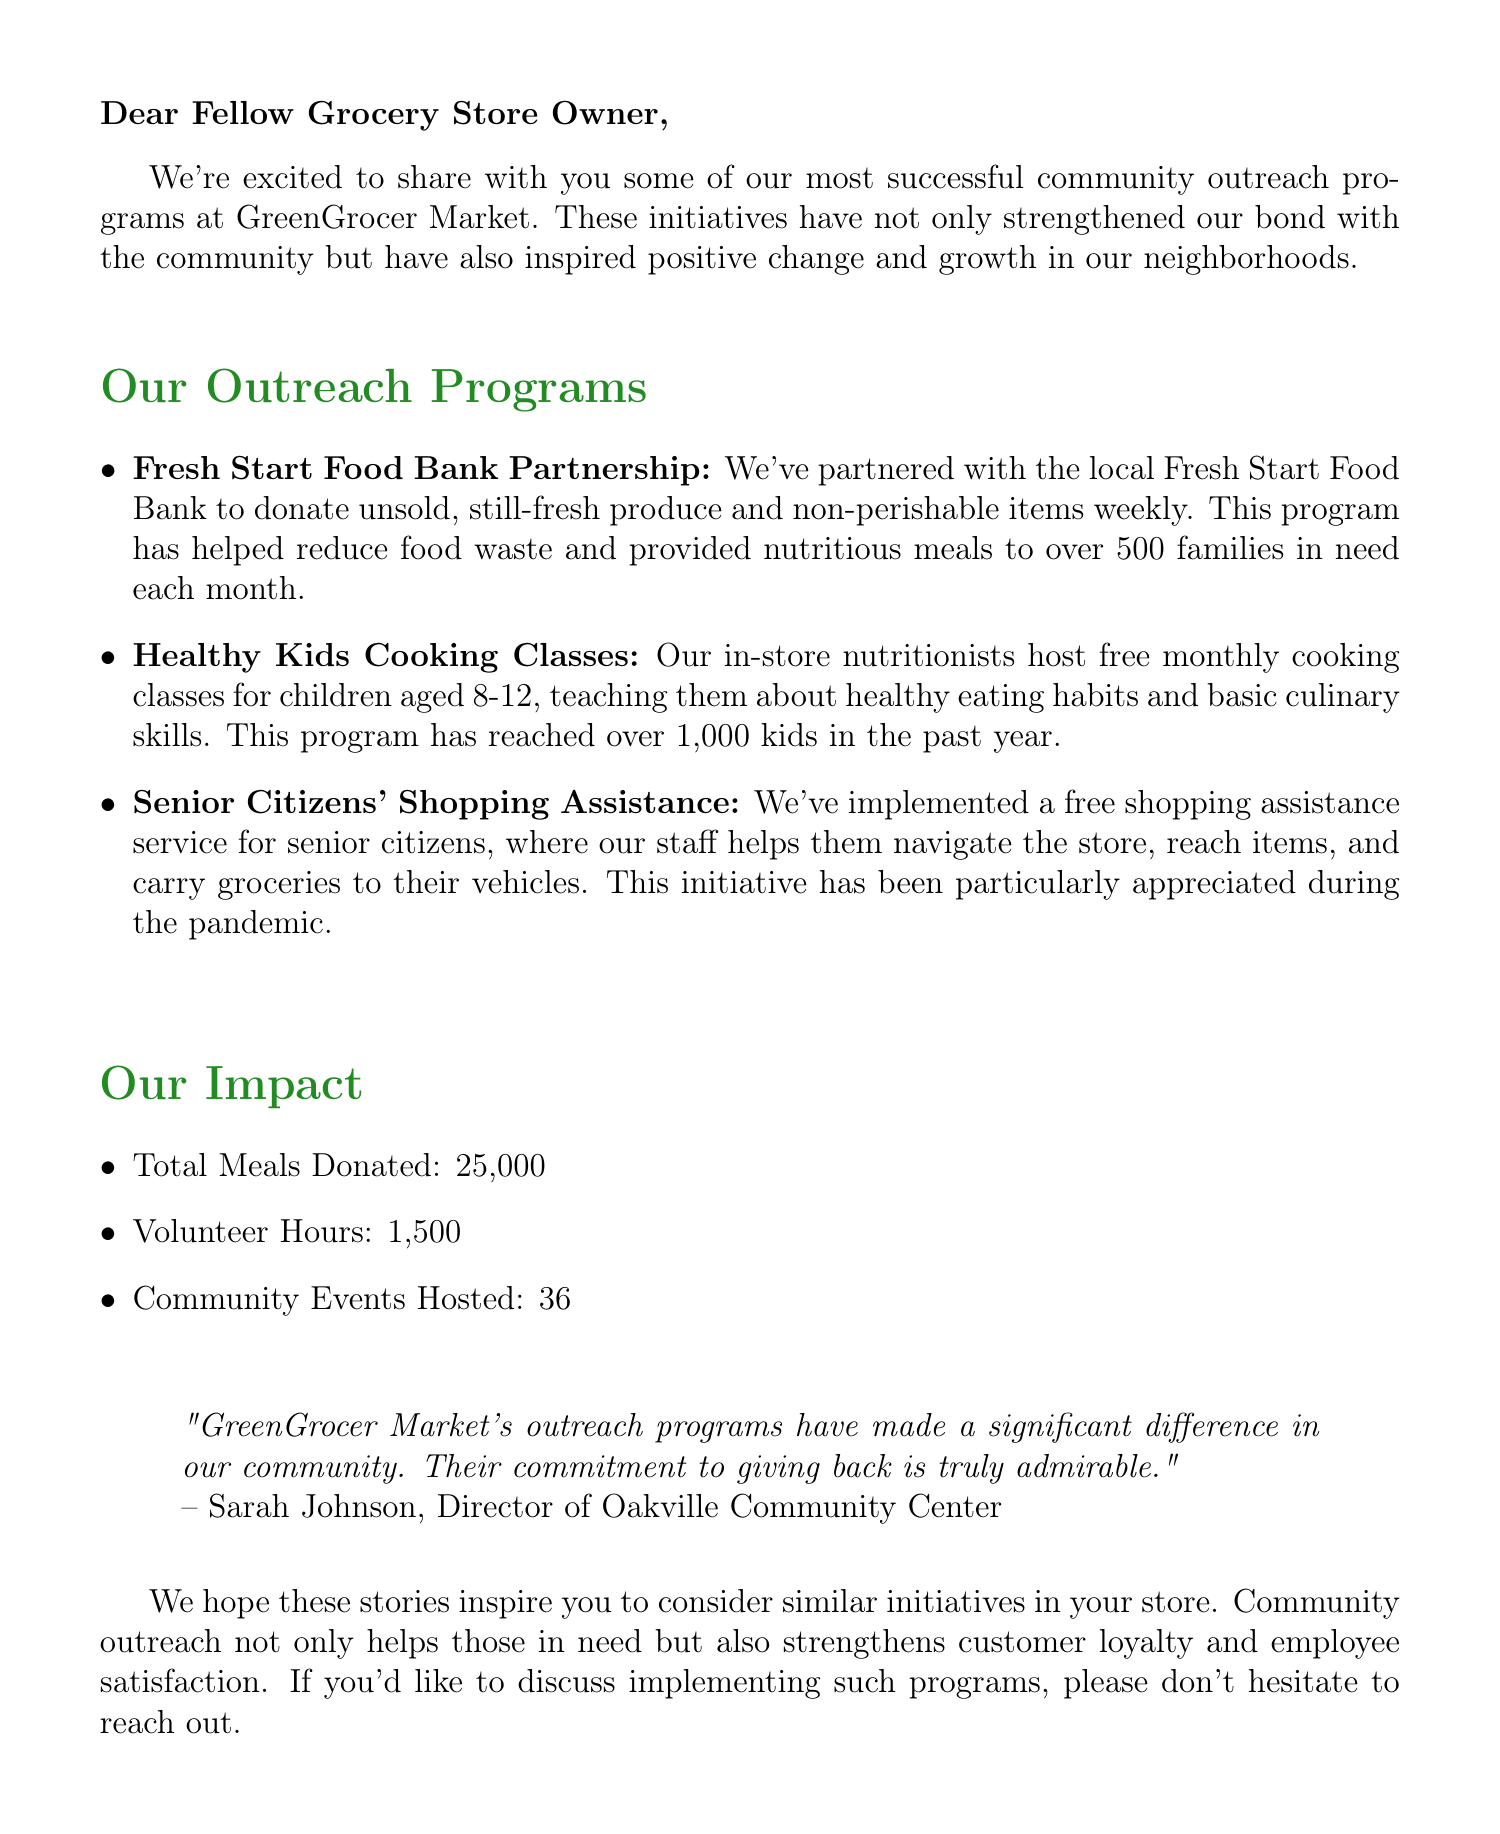What is the name of the grocery store chain? The document mentions the name of the grocery store chain as GreenGrocer Market.
Answer: GreenGrocer Market How many meals have been donated in total? The total number of meals donated is listed in the impact statistics section of the document.
Answer: 25,000 What age group do the Healthy Kids Cooking Classes target? The document specifies that the cooking classes are for children aged 8-12.
Answer: 8-12 Who is the author of the testimonial? The document contains a testimonial attributed to Sarah Johnson.
Answer: Sarah Johnson What is the contact email of the Community Outreach Coordinator? The document provides the email address of the Community Outreach Coordinator in the contact information section.
Answer: mgreen@greengrocermarket.com Which program helps senior citizens navigate the store? The document discusses a specific program for assisting senior citizens.
Answer: Senior Citizens' Shopping Assistance How many community events have been hosted? The document states the number of community events hosted within the impact statistics section.
Answer: 36 What is the primary goal of the outreach programs mentioned? The outreach programs aim to strengthen community bonds and inspire positive change.
Answer: Strengthening community bonds What is the total number of volunteer hours contributed? The document includes the total volunteer hours in the impact statistics section.
Answer: 1,500 